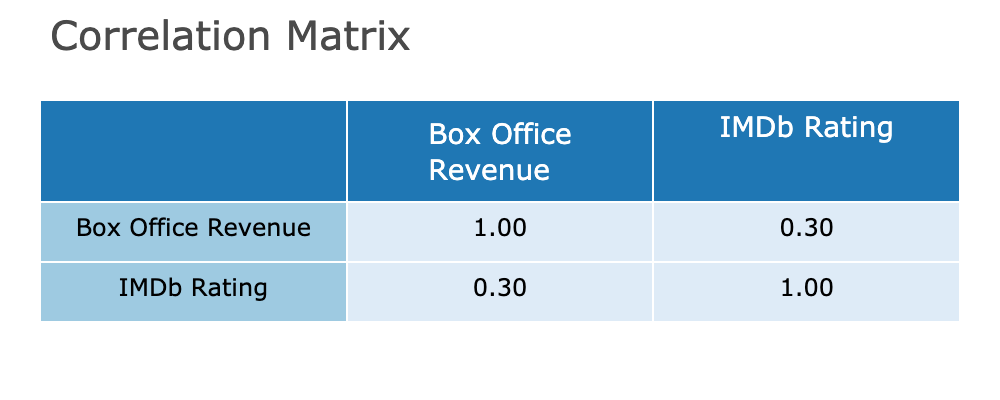What is the correlation coefficient between Box Office Revenue and IMDb Rating? The correlation matrix shows the values of the correlation between Box Office Revenue and IMDb Rating in the table. The specific value in the table's cells indicates the correlation coefficient.
Answer: 0.12 Which film has the highest Box Office Revenue? Looking at the table under the Box Office Revenue column, the film with the highest revenue is Barbie with a value of 1200 million.
Answer: Barbie What is the IMDb rating of the film with the second highest Box Office Revenue? The film with the second highest Box Office Revenue is Oppenheimer, which can be verified by checking the Box Office Revenue column. Its corresponding IMDb Rating is 8.5, according to the table.
Answer: 8.5 Is there a film with a Box Office Revenue greater than 1000 million that has an IMDb rating below 7? Upon reviewing the table, all films exceeding 1000 million in box office revenue (Barbie and The Super Mario Bros. Movie) have IMDb ratings of 7.5 and 7.1 respectively. Therefore, there are no films that meet the criteria.
Answer: No What is the average IMDb rating of the films that have a Box Office Revenue less than 500 million? The films that fit the criteria are A Haunting in Venice, Transformers: Rise of the Beasts, The Whale, and Asteroid City with IMDb ratings of 6.3, 6.0, 8.0, and 6.7 respectively. To find the average, sum these ratings (6.3 + 6.0 + 8.0 + 6.7) resulting in 27.0, then divide by 4 (number of films), giving an average rating of 6.75.
Answer: 6.75 Which film has the lowest Box Office Revenue and what is its IMDb rating? From the table, A Haunting in Venice has the lowest Box Office Revenue at 150 million. Its IMDb rating can be found in the same row as the Box Office Revenue column, which is 6.3.
Answer: A Haunting in Venice, 6.3 What is the difference in Box Office Revenue between the film with the highest rating and the one with the lowest rating? The film with the highest IMDb rating is Spider-Man: Across the Spider-Verse (8.8) and the film with the lowest is Transformers: Rise of the Beasts (6.0). Their Box Office Revenue is found to be 700 million and 400 million respectively. The difference can be calculated by subtracting 400 million from 700 million, which equals 300 million.
Answer: 300 million Do any films have an IMDb rating of 8.0 or higher that made less than 500 million? Reviewing the column for IMDb rating, the film with a rating of 8.0 is Killers of the Flower Moon, and its Box Office Revenue is 300 million, which is less than 500 million. Therefore, this film fits the criteria.
Answer: Yes 